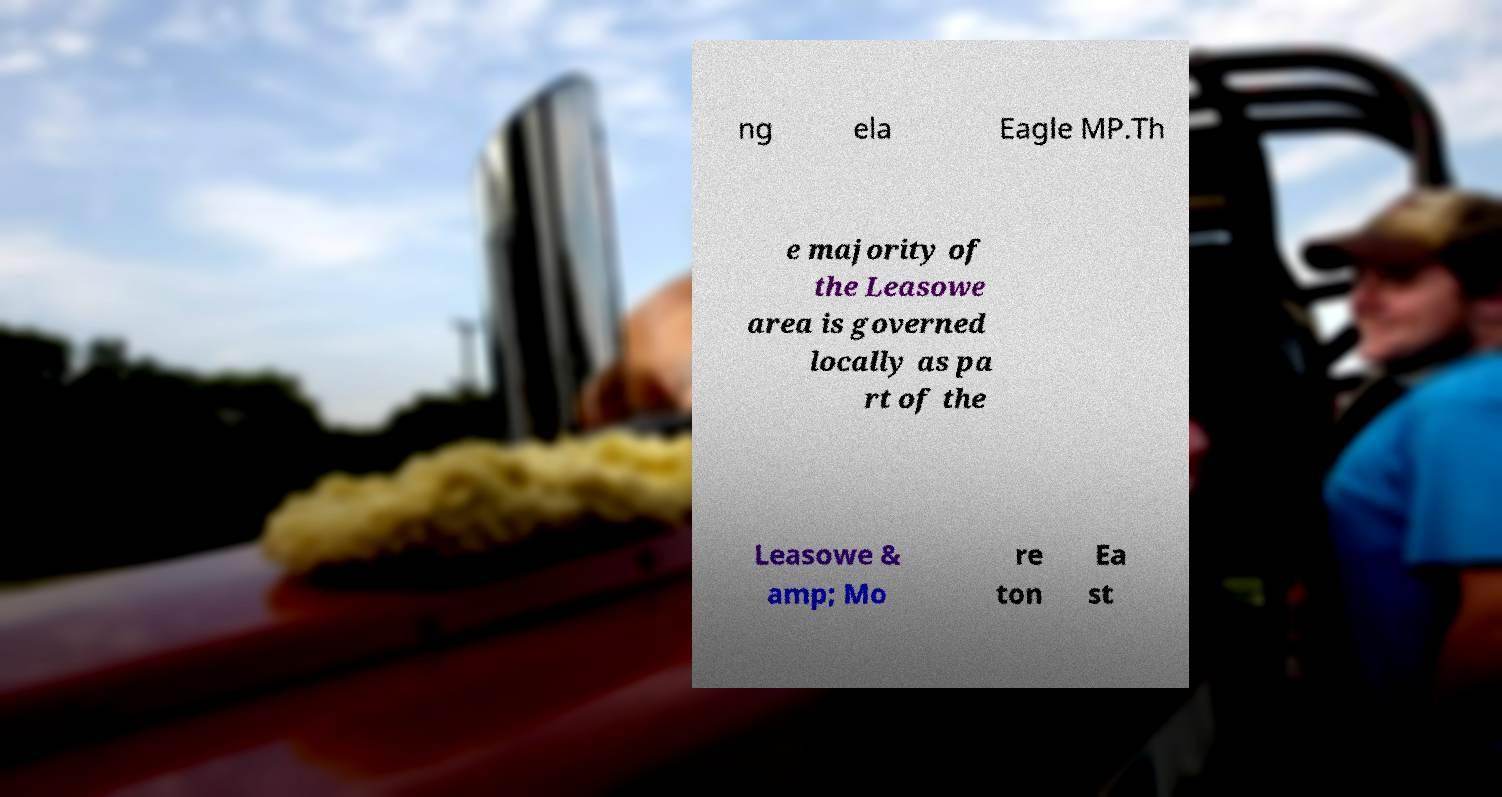For documentation purposes, I need the text within this image transcribed. Could you provide that? ng ela Eagle MP.Th e majority of the Leasowe area is governed locally as pa rt of the Leasowe & amp; Mo re ton Ea st 